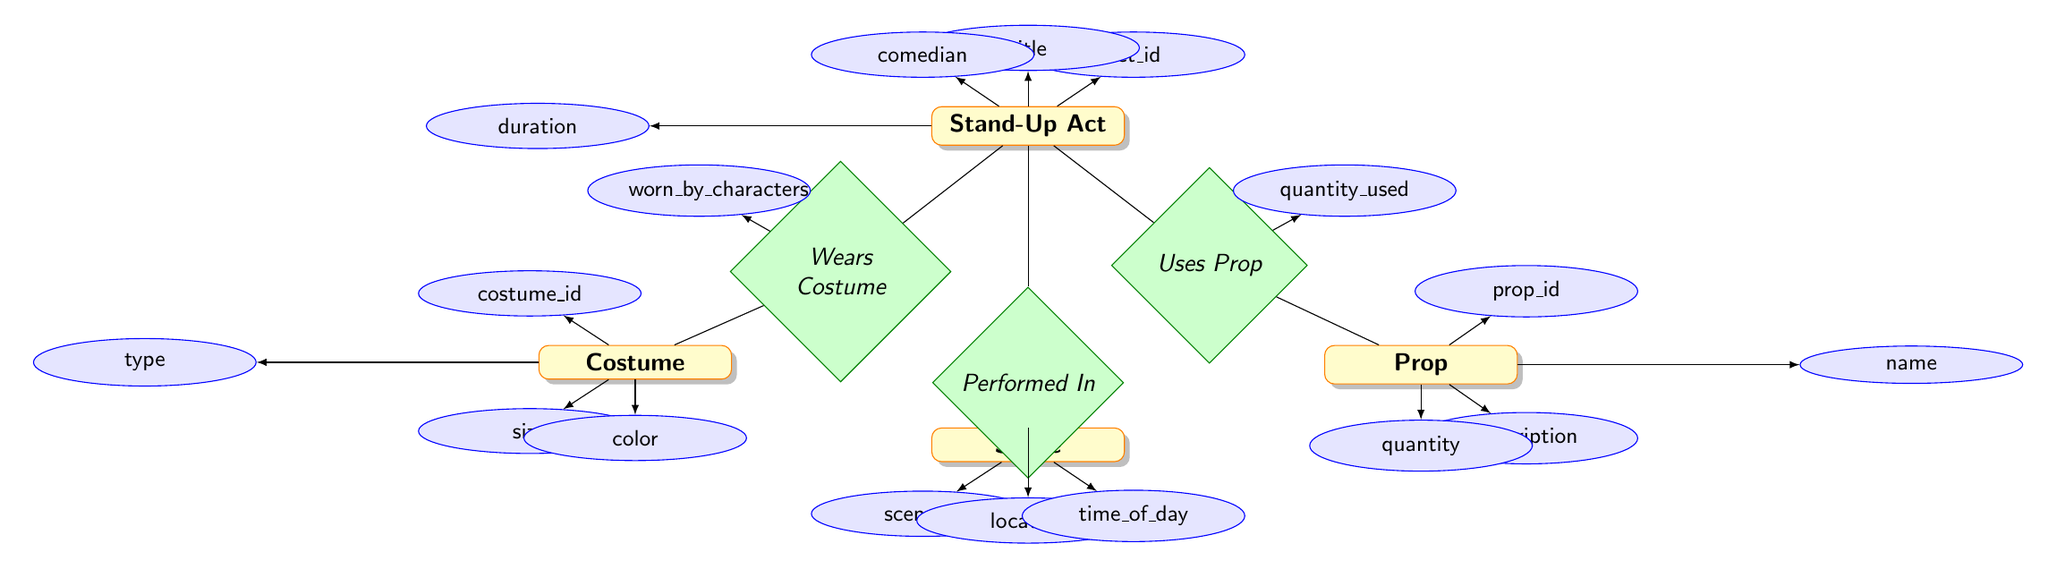What's the title of the Stand-Up Act? The title of the Stand-Up Act can be found as an attribute connected to the "Stand-Up Act" entity. Each entity's attributes provide specific values, and the title is one of them.
Answer: title How many attributes does the Prop entity have? By examining the Prop entity in the diagram, you can count the number of attributes it contains, which are prop_id, name, description, and quantity. This gives a total of four attributes.
Answer: 4 What relationship exists between Stand-Up Act and Prop? The relationship between Stand-Up Act and Prop can be identified in the diagram by looking for connecting lines. The relationship named "Uses Prop" connects these two entities.
Answer: Uses Prop What is the quantity used in the relationship "Uses Prop"? The relationship "Uses Prop" has an attribute named "quantity_used" that provides additional information about how many of the prop are used in a specific stand-up act.
Answer: quantity_used Which entity does the "Wears Costume" relationship connect? The "Wears Costume" relationship connects the Stand-Up Act entity with the Costume entity, indicating which costumes are worn in the act.
Answer: Costume List the attributes of the Scene entity. To answer this, examine the Scene entity and directly list each attribute connected to it, which are scene_id, location, and time_of_day.
Answer: scene_id, location, time_of_day What does the "worn_by_characters" attribute represent? The "worn_by_characters" attribute describes the characters that wear costumes in the stand-up act. It is part of the relationship "Wears Costume" and provides additional context.
Answer: characters What type of diagram is this? The diagram is an Entity Relationship Diagram, which visually represents the relationships between different entities involved in prop and costume coordination for stand-up acts.
Answer: Entity Relationship Diagram How many nodes are present in the diagram? To determine the number of nodes, count all the entities and relationships depicted, including attributes associated with each entity. There are four entities and three relationships, totaling seven nodes.
Answer: 7 